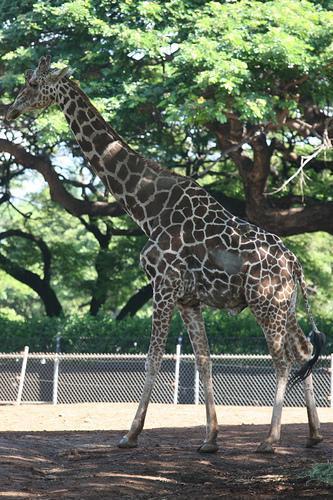How many giraffes are in the picture?
Give a very brief answer. 1. How many tails does the giraffe have?
Give a very brief answer. 1. How many people are there?
Give a very brief answer. 0. 